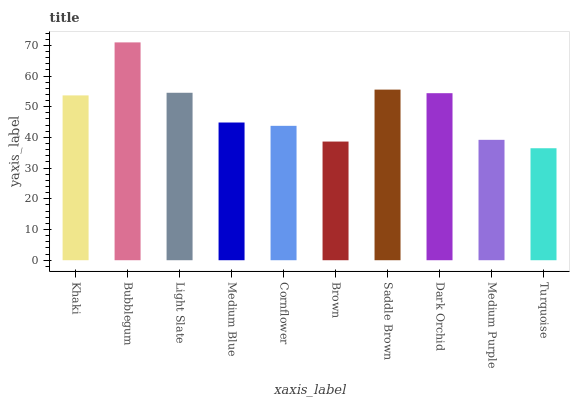Is Turquoise the minimum?
Answer yes or no. Yes. Is Bubblegum the maximum?
Answer yes or no. Yes. Is Light Slate the minimum?
Answer yes or no. No. Is Light Slate the maximum?
Answer yes or no. No. Is Bubblegum greater than Light Slate?
Answer yes or no. Yes. Is Light Slate less than Bubblegum?
Answer yes or no. Yes. Is Light Slate greater than Bubblegum?
Answer yes or no. No. Is Bubblegum less than Light Slate?
Answer yes or no. No. Is Khaki the high median?
Answer yes or no. Yes. Is Medium Blue the low median?
Answer yes or no. Yes. Is Bubblegum the high median?
Answer yes or no. No. Is Cornflower the low median?
Answer yes or no. No. 